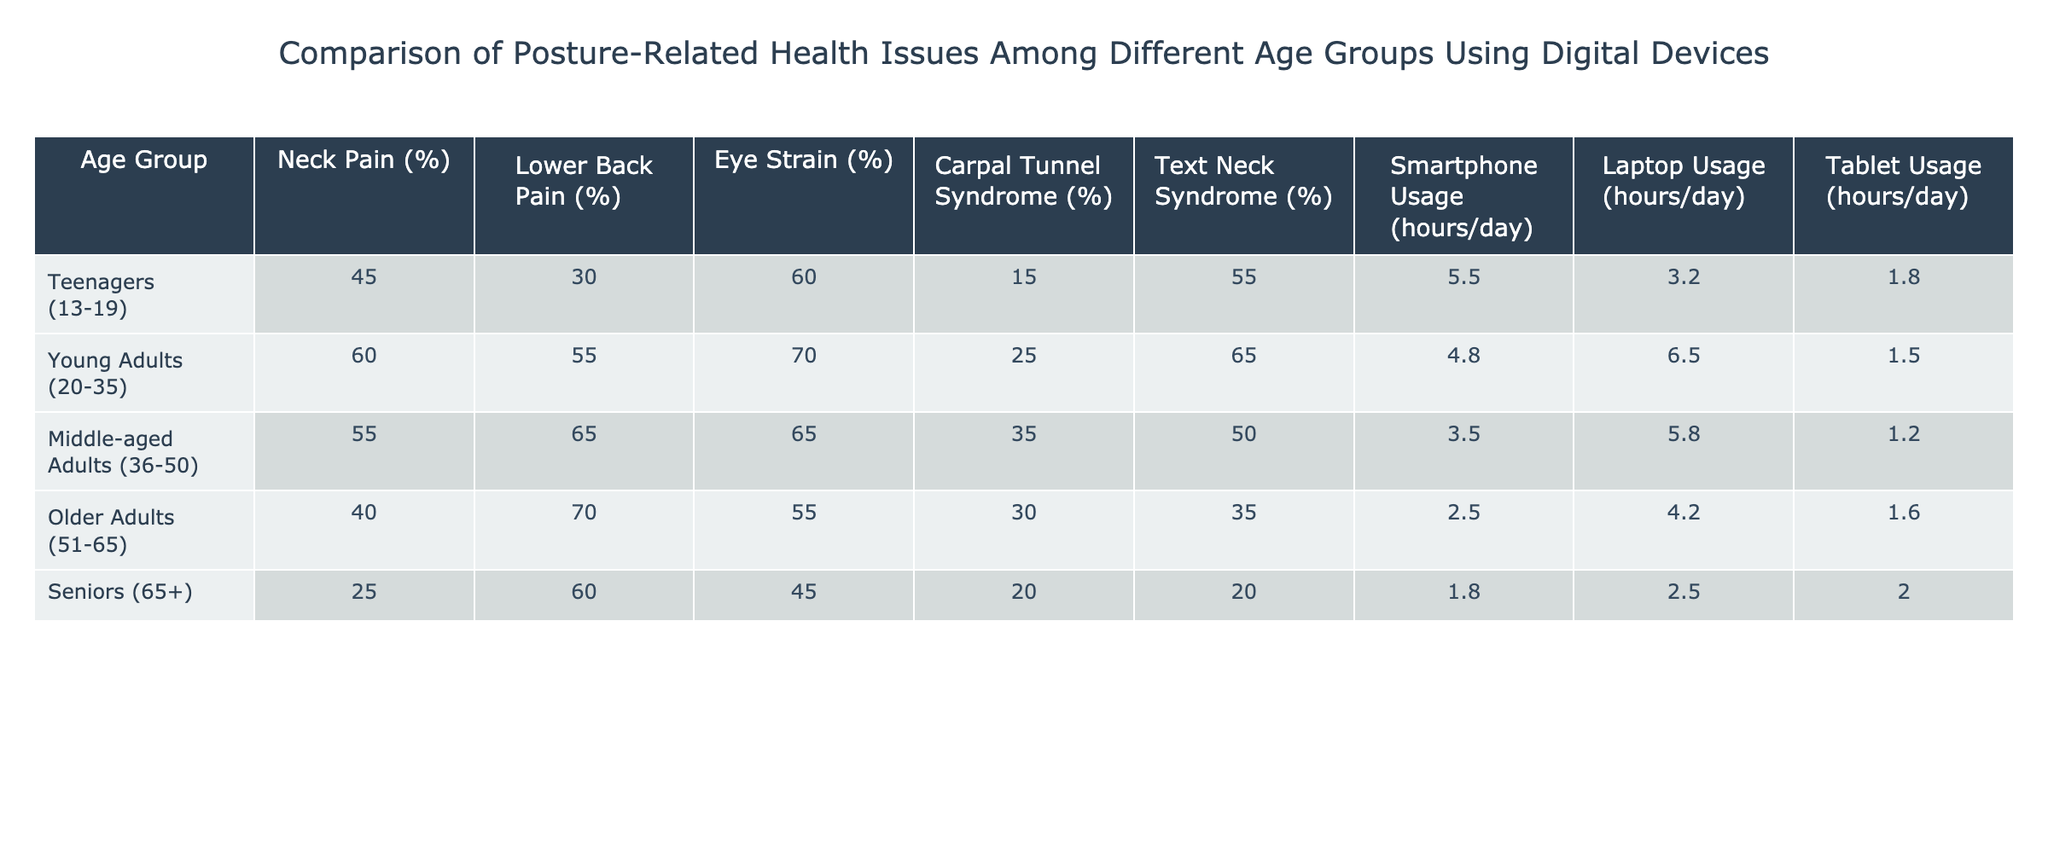What is the percentage of teenagers experiencing eye strain? The table shows that the percentage of teenagers (13-19) experiencing eye strain is 60%.
Answer: 60% Which age group has the highest percentage of lower back pain? According to the table, young adults (20-35) have the highest percentage of lower back pain at 55%.
Answer: 55% Is it true that seniors have the lowest usage of smartphones per day? The table indicates that seniors (65+) use smartphones for 1.8 hours per day, which is lower than all other age groups. Therefore, the statement is true.
Answer: True What is the average percentage of text neck syndrome across all age groups? To find the average, sum the percentages of text neck syndrome: (55 + 65 + 50 + 35 + 20) = 225. There are 5 age groups, so the average is 225/5 = 45%.
Answer: 45% How does the smartphone usage of middle-aged adults compare to that of young adults? Middle-aged adults (36-50) use smartphones for 3.5 hours/day, while young adults (20-35) use them for 4.8 hours/day. Young adults have higher smartphone usage than middle-aged adults by 1.3 hours.
Answer: Young adults use smartphones more by 1.3 hours 